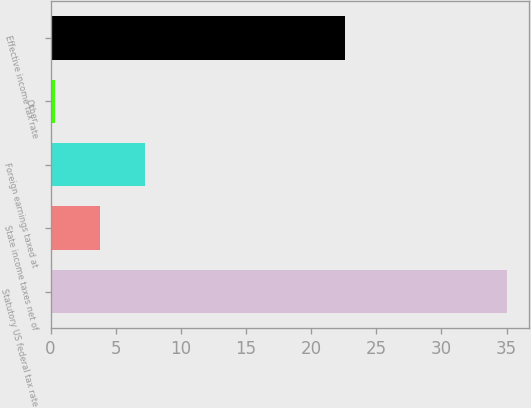Convert chart to OTSL. <chart><loc_0><loc_0><loc_500><loc_500><bar_chart><fcel>Statutory US federal tax rate<fcel>State income taxes net of<fcel>Foreign earnings taxed at<fcel>Other<fcel>Effective income tax rate<nl><fcel>35<fcel>3.77<fcel>7.24<fcel>0.3<fcel>22.6<nl></chart> 